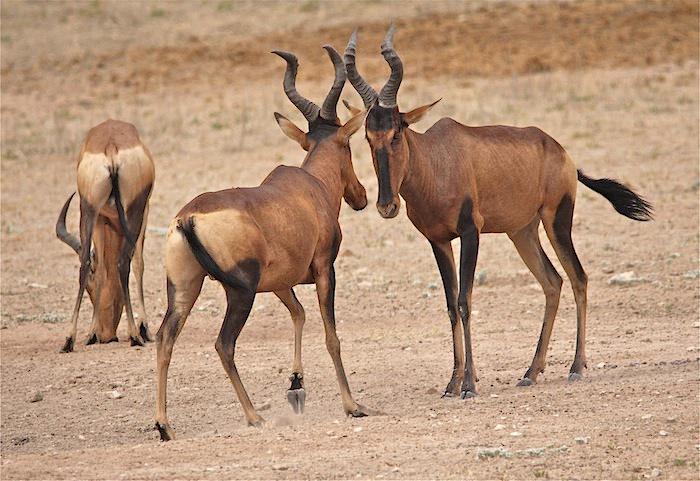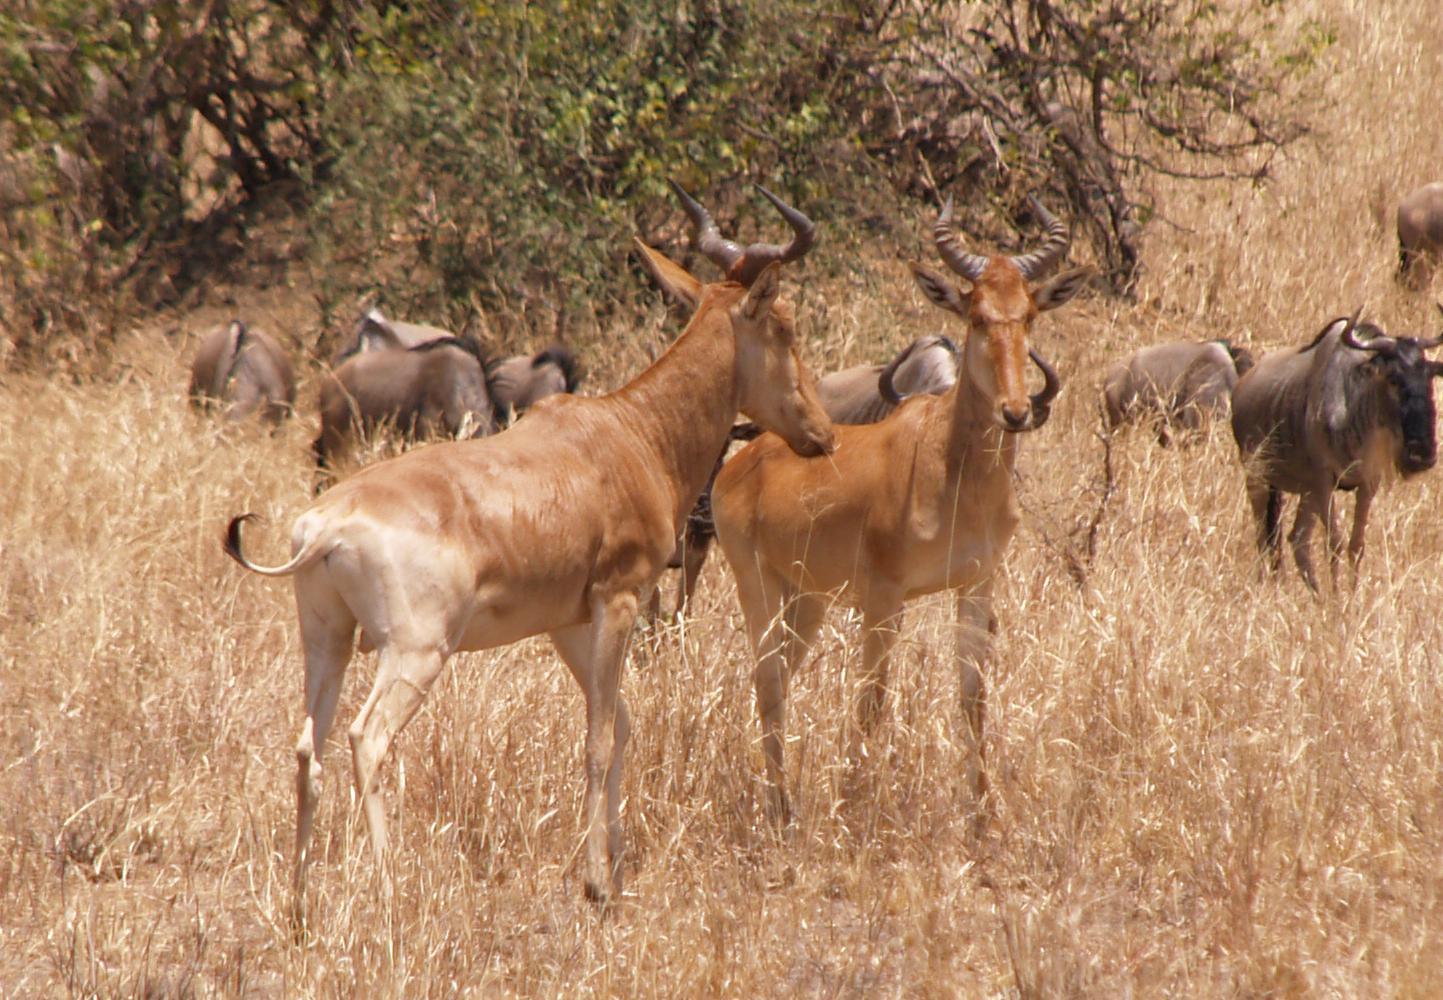The first image is the image on the left, the second image is the image on the right. Given the left and right images, does the statement "An image shows one horned animal standing and facing the camera." hold true? Answer yes or no. No. The first image is the image on the left, the second image is the image on the right. Analyze the images presented: Is the assertion "There are two antelopes in the wild." valid? Answer yes or no. No. 